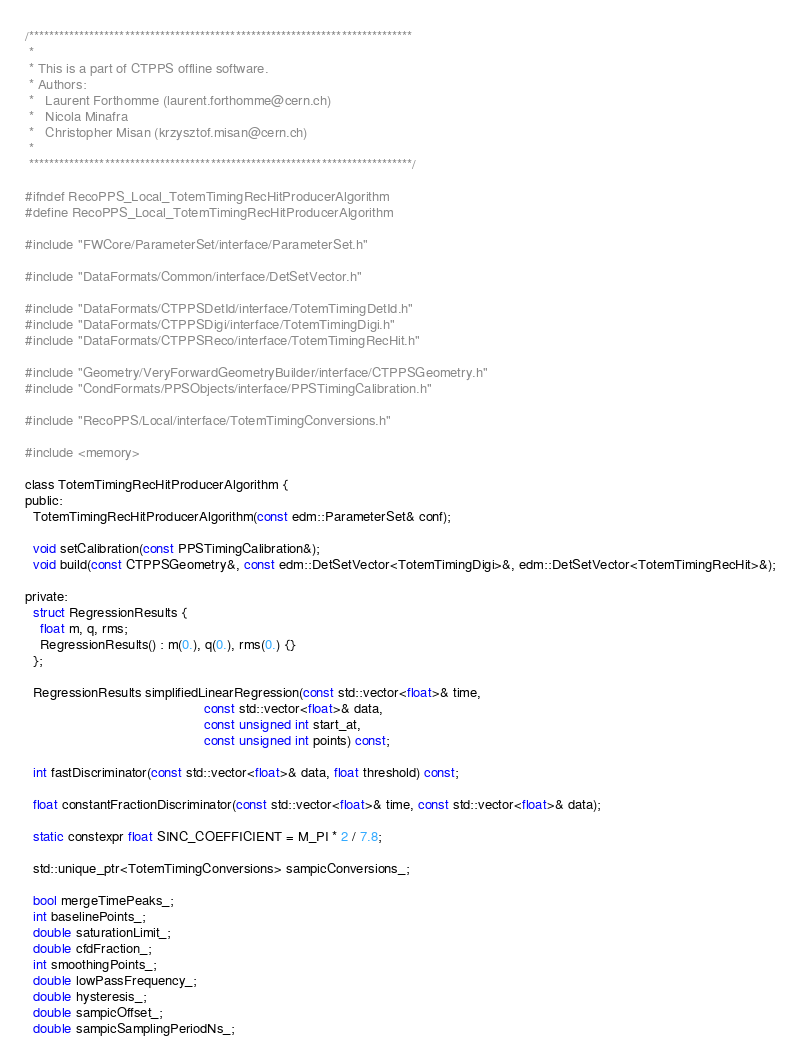<code> <loc_0><loc_0><loc_500><loc_500><_C_>/****************************************************************************
 *
 * This is a part of CTPPS offline software.
 * Authors:
 *   Laurent Forthomme (laurent.forthomme@cern.ch)
 *   Nicola Minafra
 *   Christopher Misan (krzysztof.misan@cern.ch)
 *
 ****************************************************************************/

#ifndef RecoPPS_Local_TotemTimingRecHitProducerAlgorithm
#define RecoPPS_Local_TotemTimingRecHitProducerAlgorithm

#include "FWCore/ParameterSet/interface/ParameterSet.h"

#include "DataFormats/Common/interface/DetSetVector.h"

#include "DataFormats/CTPPSDetId/interface/TotemTimingDetId.h"
#include "DataFormats/CTPPSDigi/interface/TotemTimingDigi.h"
#include "DataFormats/CTPPSReco/interface/TotemTimingRecHit.h"

#include "Geometry/VeryForwardGeometryBuilder/interface/CTPPSGeometry.h"
#include "CondFormats/PPSObjects/interface/PPSTimingCalibration.h"

#include "RecoPPS/Local/interface/TotemTimingConversions.h"

#include <memory>

class TotemTimingRecHitProducerAlgorithm {
public:
  TotemTimingRecHitProducerAlgorithm(const edm::ParameterSet& conf);

  void setCalibration(const PPSTimingCalibration&);
  void build(const CTPPSGeometry&, const edm::DetSetVector<TotemTimingDigi>&, edm::DetSetVector<TotemTimingRecHit>&);

private:
  struct RegressionResults {
    float m, q, rms;
    RegressionResults() : m(0.), q(0.), rms(0.) {}
  };

  RegressionResults simplifiedLinearRegression(const std::vector<float>& time,
                                               const std::vector<float>& data,
                                               const unsigned int start_at,
                                               const unsigned int points) const;

  int fastDiscriminator(const std::vector<float>& data, float threshold) const;

  float constantFractionDiscriminator(const std::vector<float>& time, const std::vector<float>& data);

  static constexpr float SINC_COEFFICIENT = M_PI * 2 / 7.8;

  std::unique_ptr<TotemTimingConversions> sampicConversions_;

  bool mergeTimePeaks_;
  int baselinePoints_;
  double saturationLimit_;
  double cfdFraction_;
  int smoothingPoints_;
  double lowPassFrequency_;
  double hysteresis_;
  double sampicOffset_;
  double sampicSamplingPeriodNs_;</code> 